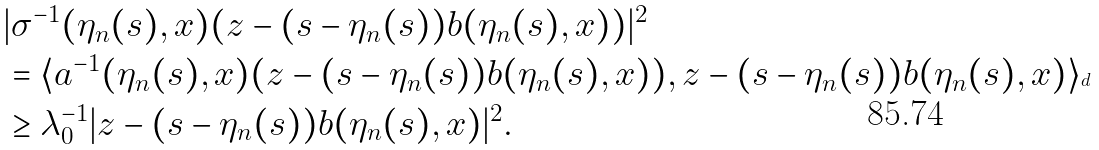Convert formula to latex. <formula><loc_0><loc_0><loc_500><loc_500>& | \sigma ^ { - 1 } ( \eta _ { n } ( s ) , x ) ( z - ( s - \eta _ { n } ( s ) ) b ( \eta _ { n } ( s ) , x ) ) | ^ { 2 } \\ & = \langle a ^ { - 1 } ( \eta _ { n } ( s ) , x ) ( z - ( s - \eta _ { n } ( s ) ) b ( \eta _ { n } ( s ) , x ) ) , z - ( s - \eta _ { n } ( s ) ) b ( \eta _ { n } ( s ) , x ) \rangle _ { \real ^ { d } } \\ & \geq \lambda _ { 0 } ^ { - 1 } | z - ( s - \eta _ { n } ( s ) ) b ( \eta _ { n } ( s ) , x ) | ^ { 2 } .</formula> 